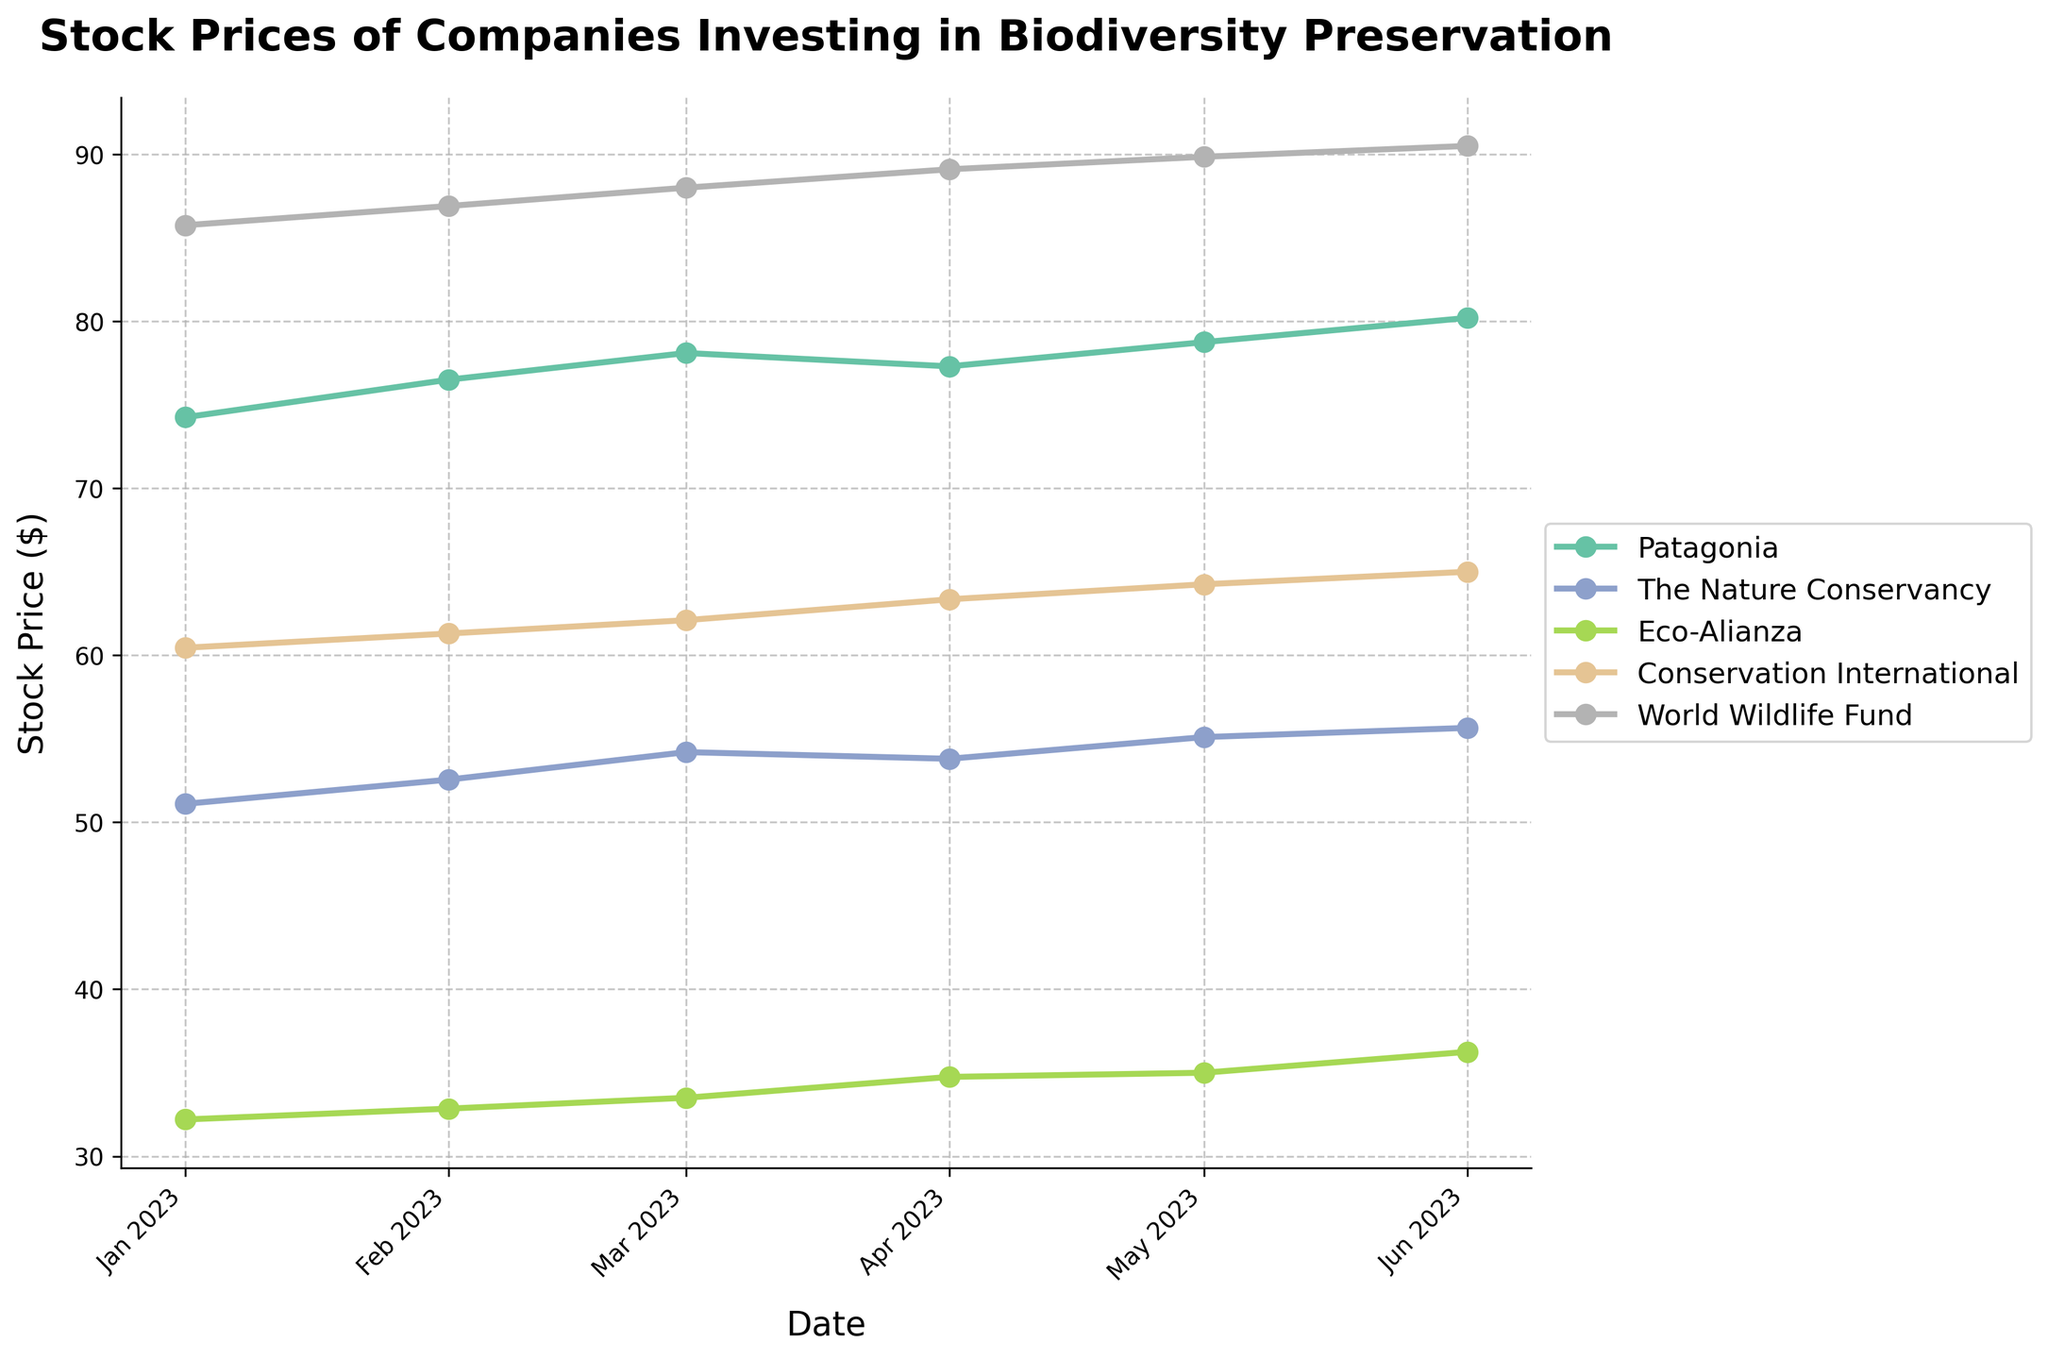What is the title of the figure? The title of the figure is located at the top of the plot in bold and larger font size compared to other text. It provides a concise description of the content of the figure.
Answer: Stock Prices of Companies Investing in Biodiversity Preservation Which company had the highest stock price in June 2023? To answer this, look at the stock prices in the figure for June 2023 and identify which company has the highest value. The World Wildlife Fund has the highest stock price.
Answer: World Wildlife Fund How many companies are represented in the plot? Each unique line on the plot represents a different company. Count the number of distinct lines or colors.
Answer: 5 What's the trend of Conservation International's stock price from January to June 2023? Identify the line for Conservation International and observe the stock price points from January to June 2023. Note the general movement of the line (upward or downward).
Answer: Upward trend Which month shows the highest stock price increase for Eco-Alianza? Identify the stock prices for each month for Eco-Alianza and calculate the difference between consecutive months. Find the month with the highest difference. From April to June (36.25 - 34.75 = 1.5).
Answer: June Compare the stock prices of Patagonia and The Nature Conservancy in May 2023. Which one is higher? Identify the stock prices for both companies in May 2023 and directly compare the values. Patagonia (78.75) is higher than The Nature Conservancy (55.10).
Answer: Patagonia What is the average stock price of Patagonia across the given months? Sum the stock prices of Patagonia from January to June 2023 and divide by the number of months (6). (74.25 + 76.50 + 78.10 + 77.30 + 78.75 + 80.20) / 6 = 77.85.
Answer: 77.85 Which company had the smallest variation in stock prices from January to June 2023? For each company, calculate the range (difference between the highest and lowest stock prices). The company with the smallest range has the smallest variation. The Nature Conservancy’s prices range between 51.10 and 55.65 (difference = 4.55), which is the smallest.
Answer: The Nature Conservancy What was the closing stock price of The Nature Conservancy in April 2023? Identify the stock price of The Nature Conservancy in April 2023 on the plot.
Answer: 53.80 